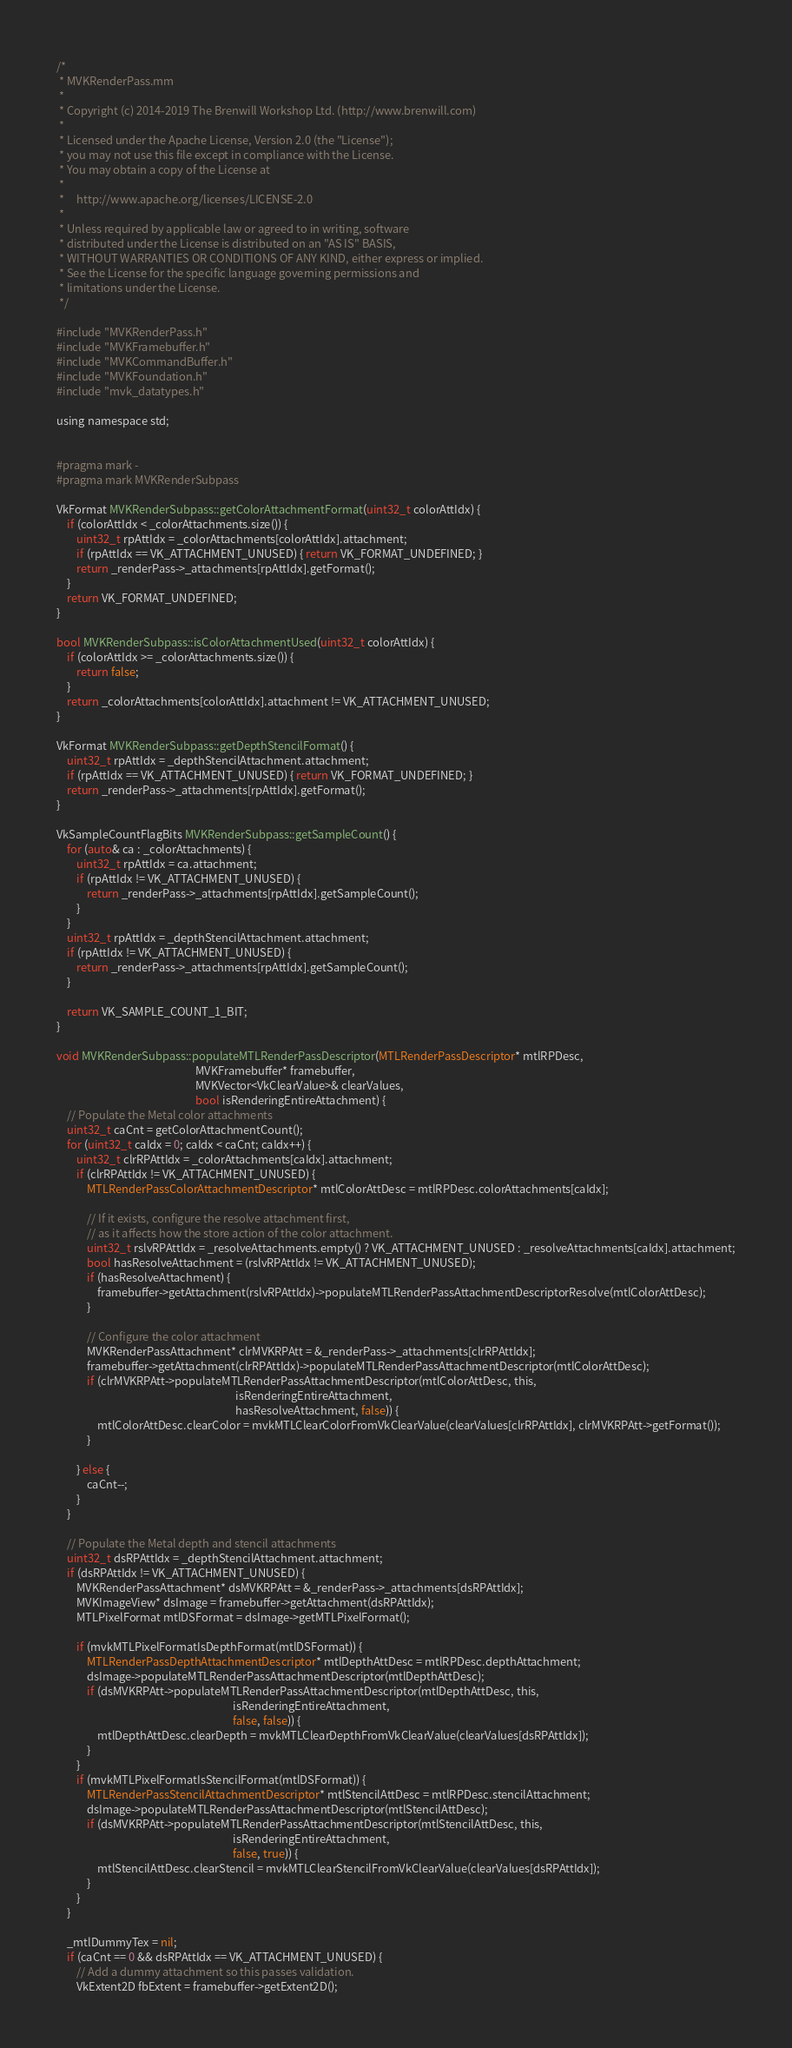Convert code to text. <code><loc_0><loc_0><loc_500><loc_500><_ObjectiveC_>/*
 * MVKRenderPass.mm
 *
 * Copyright (c) 2014-2019 The Brenwill Workshop Ltd. (http://www.brenwill.com)
 *
 * Licensed under the Apache License, Version 2.0 (the "License");
 * you may not use this file except in compliance with the License.
 * You may obtain a copy of the License at
 * 
 *     http://www.apache.org/licenses/LICENSE-2.0
 * 
 * Unless required by applicable law or agreed to in writing, software
 * distributed under the License is distributed on an "AS IS" BASIS,
 * WITHOUT WARRANTIES OR CONDITIONS OF ANY KIND, either express or implied.
 * See the License for the specific language governing permissions and
 * limitations under the License.
 */

#include "MVKRenderPass.h"
#include "MVKFramebuffer.h"
#include "MVKCommandBuffer.h"
#include "MVKFoundation.h"
#include "mvk_datatypes.h"

using namespace std;


#pragma mark -
#pragma mark MVKRenderSubpass

VkFormat MVKRenderSubpass::getColorAttachmentFormat(uint32_t colorAttIdx) {
	if (colorAttIdx < _colorAttachments.size()) {
		uint32_t rpAttIdx = _colorAttachments[colorAttIdx].attachment;
		if (rpAttIdx == VK_ATTACHMENT_UNUSED) { return VK_FORMAT_UNDEFINED; }
		return _renderPass->_attachments[rpAttIdx].getFormat();
	}
	return VK_FORMAT_UNDEFINED;
}

bool MVKRenderSubpass::isColorAttachmentUsed(uint32_t colorAttIdx) {
	if (colorAttIdx >= _colorAttachments.size()) {
		return false;
	}
	return _colorAttachments[colorAttIdx].attachment != VK_ATTACHMENT_UNUSED;
}

VkFormat MVKRenderSubpass::getDepthStencilFormat() {
	uint32_t rpAttIdx = _depthStencilAttachment.attachment;
	if (rpAttIdx == VK_ATTACHMENT_UNUSED) { return VK_FORMAT_UNDEFINED; }
	return _renderPass->_attachments[rpAttIdx].getFormat();
}

VkSampleCountFlagBits MVKRenderSubpass::getSampleCount() {
	for (auto& ca : _colorAttachments) {
		uint32_t rpAttIdx = ca.attachment;
		if (rpAttIdx != VK_ATTACHMENT_UNUSED) {
			return _renderPass->_attachments[rpAttIdx].getSampleCount();
		}
	}
	uint32_t rpAttIdx = _depthStencilAttachment.attachment;
	if (rpAttIdx != VK_ATTACHMENT_UNUSED) {
		return _renderPass->_attachments[rpAttIdx].getSampleCount();
	}

	return VK_SAMPLE_COUNT_1_BIT;
}

void MVKRenderSubpass::populateMTLRenderPassDescriptor(MTLRenderPassDescriptor* mtlRPDesc,
													   MVKFramebuffer* framebuffer,
													   MVKVector<VkClearValue>& clearValues,
													   bool isRenderingEntireAttachment) {
	// Populate the Metal color attachments
	uint32_t caCnt = getColorAttachmentCount();
	for (uint32_t caIdx = 0; caIdx < caCnt; caIdx++) {
		uint32_t clrRPAttIdx = _colorAttachments[caIdx].attachment;
        if (clrRPAttIdx != VK_ATTACHMENT_UNUSED) {
            MTLRenderPassColorAttachmentDescriptor* mtlColorAttDesc = mtlRPDesc.colorAttachments[caIdx];

            // If it exists, configure the resolve attachment first,
            // as it affects how the store action of the color attachment.
            uint32_t rslvRPAttIdx = _resolveAttachments.empty() ? VK_ATTACHMENT_UNUSED : _resolveAttachments[caIdx].attachment;
            bool hasResolveAttachment = (rslvRPAttIdx != VK_ATTACHMENT_UNUSED);
            if (hasResolveAttachment) {
                framebuffer->getAttachment(rslvRPAttIdx)->populateMTLRenderPassAttachmentDescriptorResolve(mtlColorAttDesc);
            }

            // Configure the color attachment
            MVKRenderPassAttachment* clrMVKRPAtt = &_renderPass->_attachments[clrRPAttIdx];
			framebuffer->getAttachment(clrRPAttIdx)->populateMTLRenderPassAttachmentDescriptor(mtlColorAttDesc);
			if (clrMVKRPAtt->populateMTLRenderPassAttachmentDescriptor(mtlColorAttDesc, this,
                                                                       isRenderingEntireAttachment,
                                                                       hasResolveAttachment, false)) {
				mtlColorAttDesc.clearColor = mvkMTLClearColorFromVkClearValue(clearValues[clrRPAttIdx], clrMVKRPAtt->getFormat());
			}

		} else {
			caCnt--;
		}
	}

	// Populate the Metal depth and stencil attachments
	uint32_t dsRPAttIdx = _depthStencilAttachment.attachment;
	if (dsRPAttIdx != VK_ATTACHMENT_UNUSED) {
		MVKRenderPassAttachment* dsMVKRPAtt = &_renderPass->_attachments[dsRPAttIdx];
		MVKImageView* dsImage = framebuffer->getAttachment(dsRPAttIdx);
		MTLPixelFormat mtlDSFormat = dsImage->getMTLPixelFormat();

		if (mvkMTLPixelFormatIsDepthFormat(mtlDSFormat)) {
			MTLRenderPassDepthAttachmentDescriptor* mtlDepthAttDesc = mtlRPDesc.depthAttachment;
			dsImage->populateMTLRenderPassAttachmentDescriptor(mtlDepthAttDesc);
			if (dsMVKRPAtt->populateMTLRenderPassAttachmentDescriptor(mtlDepthAttDesc, this,
                                                                      isRenderingEntireAttachment,
                                                                      false, false)) {
				mtlDepthAttDesc.clearDepth = mvkMTLClearDepthFromVkClearValue(clearValues[dsRPAttIdx]);
			}
		}
		if (mvkMTLPixelFormatIsStencilFormat(mtlDSFormat)) {
			MTLRenderPassStencilAttachmentDescriptor* mtlStencilAttDesc = mtlRPDesc.stencilAttachment;
			dsImage->populateMTLRenderPassAttachmentDescriptor(mtlStencilAttDesc);
			if (dsMVKRPAtt->populateMTLRenderPassAttachmentDescriptor(mtlStencilAttDesc, this,
                                                                      isRenderingEntireAttachment,
                                                                      false, true)) {
				mtlStencilAttDesc.clearStencil = mvkMTLClearStencilFromVkClearValue(clearValues[dsRPAttIdx]);
			}
		}
	}

	_mtlDummyTex = nil;
	if (caCnt == 0 && dsRPAttIdx == VK_ATTACHMENT_UNUSED) {
		// Add a dummy attachment so this passes validation.
		VkExtent2D fbExtent = framebuffer->getExtent2D();</code> 